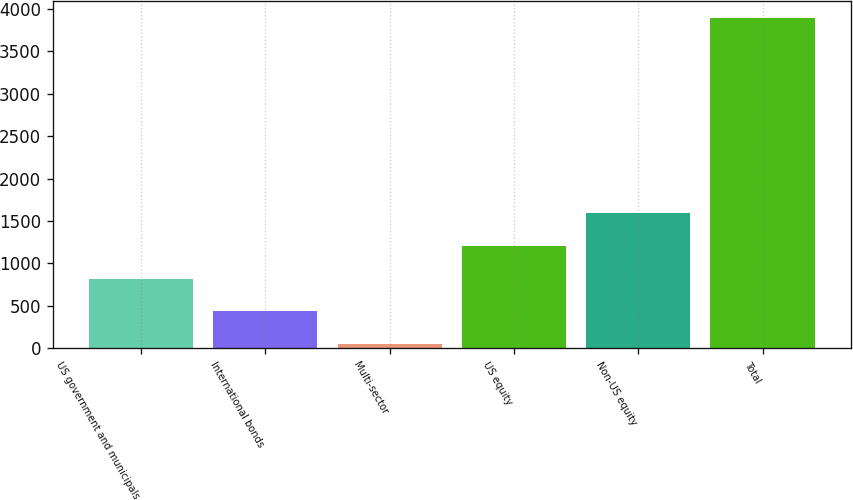Convert chart. <chart><loc_0><loc_0><loc_500><loc_500><bar_chart><fcel>US government and municipals<fcel>International bonds<fcel>Multi-sector<fcel>US equity<fcel>Non-US equity<fcel>Total<nl><fcel>820.6<fcel>436.3<fcel>52<fcel>1204.9<fcel>1589.2<fcel>3895<nl></chart> 